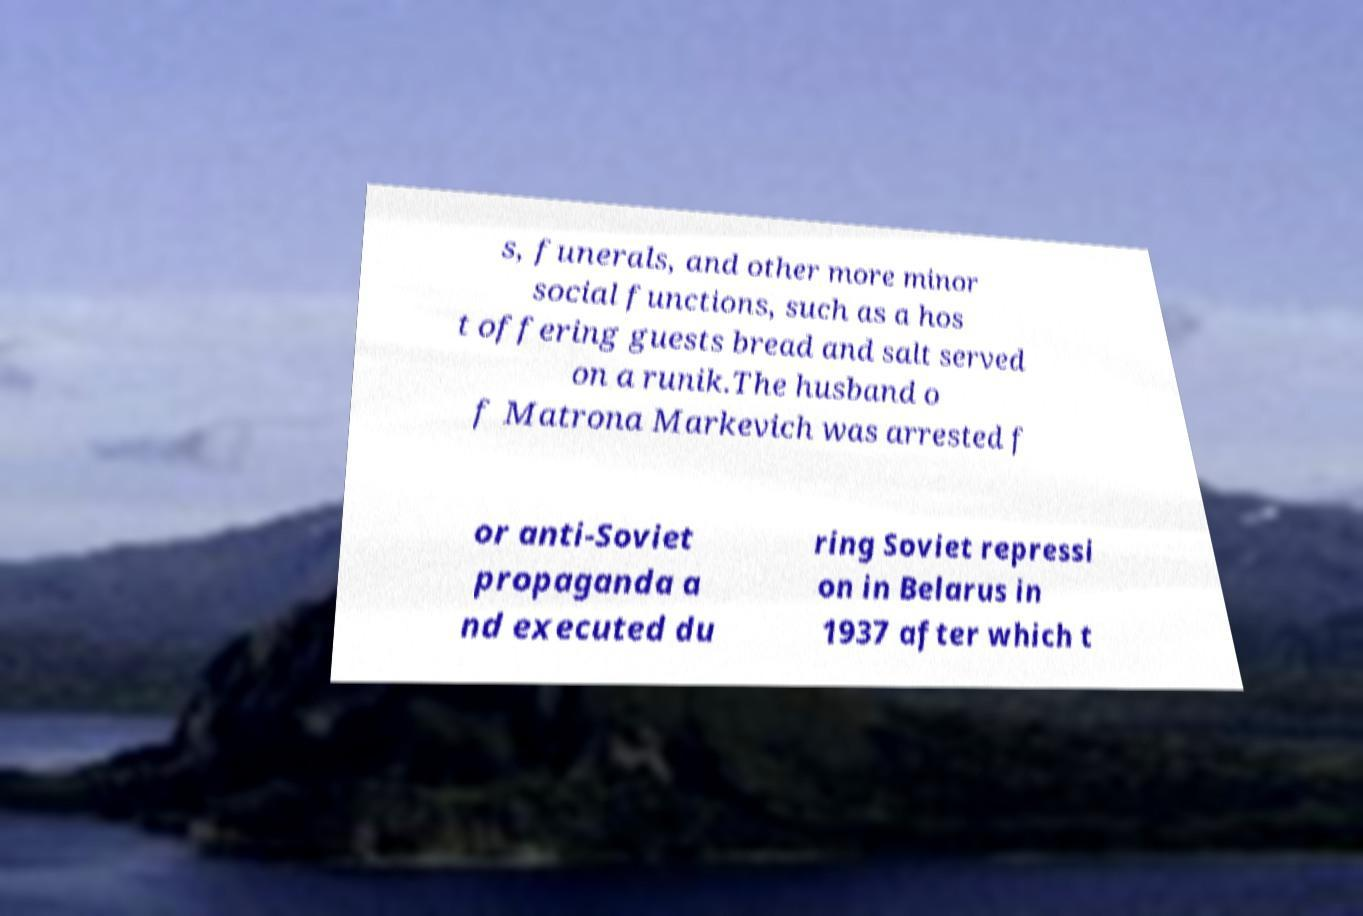I need the written content from this picture converted into text. Can you do that? s, funerals, and other more minor social functions, such as a hos t offering guests bread and salt served on a runik.The husband o f Matrona Markevich was arrested f or anti-Soviet propaganda a nd executed du ring Soviet repressi on in Belarus in 1937 after which t 